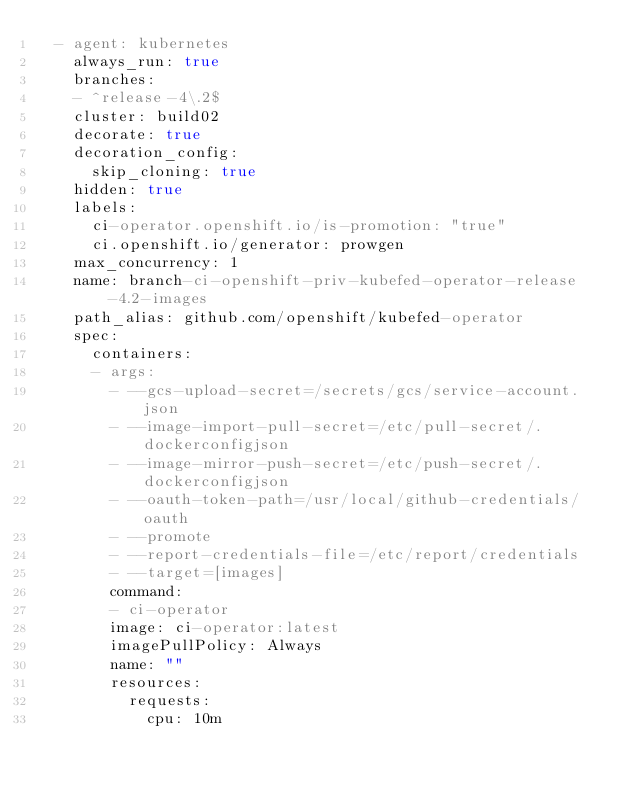Convert code to text. <code><loc_0><loc_0><loc_500><loc_500><_YAML_>  - agent: kubernetes
    always_run: true
    branches:
    - ^release-4\.2$
    cluster: build02
    decorate: true
    decoration_config:
      skip_cloning: true
    hidden: true
    labels:
      ci-operator.openshift.io/is-promotion: "true"
      ci.openshift.io/generator: prowgen
    max_concurrency: 1
    name: branch-ci-openshift-priv-kubefed-operator-release-4.2-images
    path_alias: github.com/openshift/kubefed-operator
    spec:
      containers:
      - args:
        - --gcs-upload-secret=/secrets/gcs/service-account.json
        - --image-import-pull-secret=/etc/pull-secret/.dockerconfigjson
        - --image-mirror-push-secret=/etc/push-secret/.dockerconfigjson
        - --oauth-token-path=/usr/local/github-credentials/oauth
        - --promote
        - --report-credentials-file=/etc/report/credentials
        - --target=[images]
        command:
        - ci-operator
        image: ci-operator:latest
        imagePullPolicy: Always
        name: ""
        resources:
          requests:
            cpu: 10m</code> 